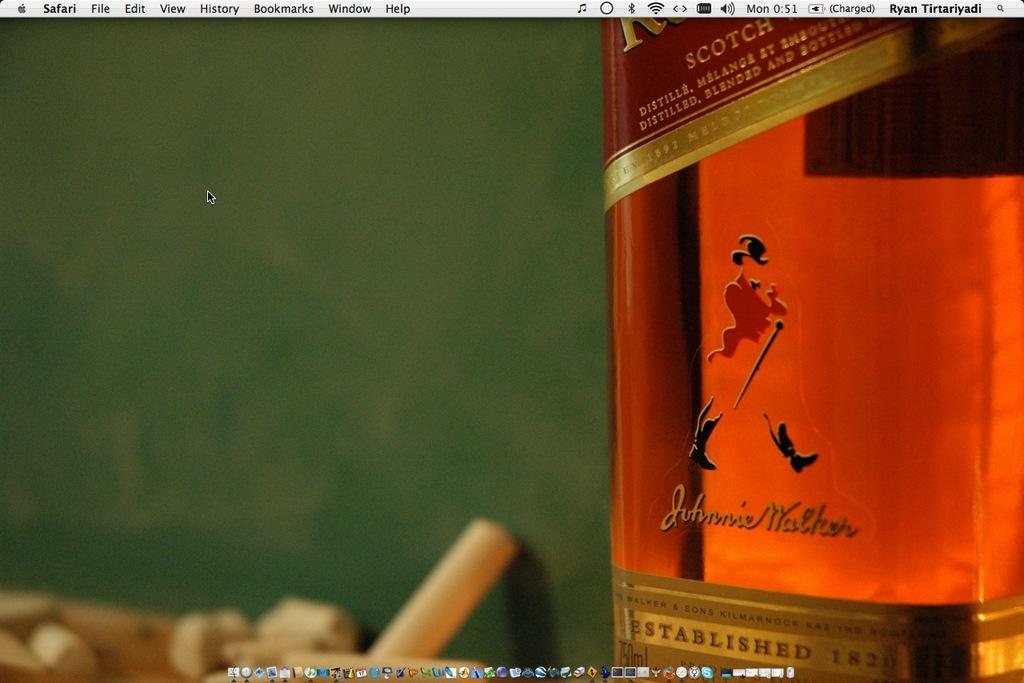Which century was johnie walker established?
Offer a terse response. 19th. 